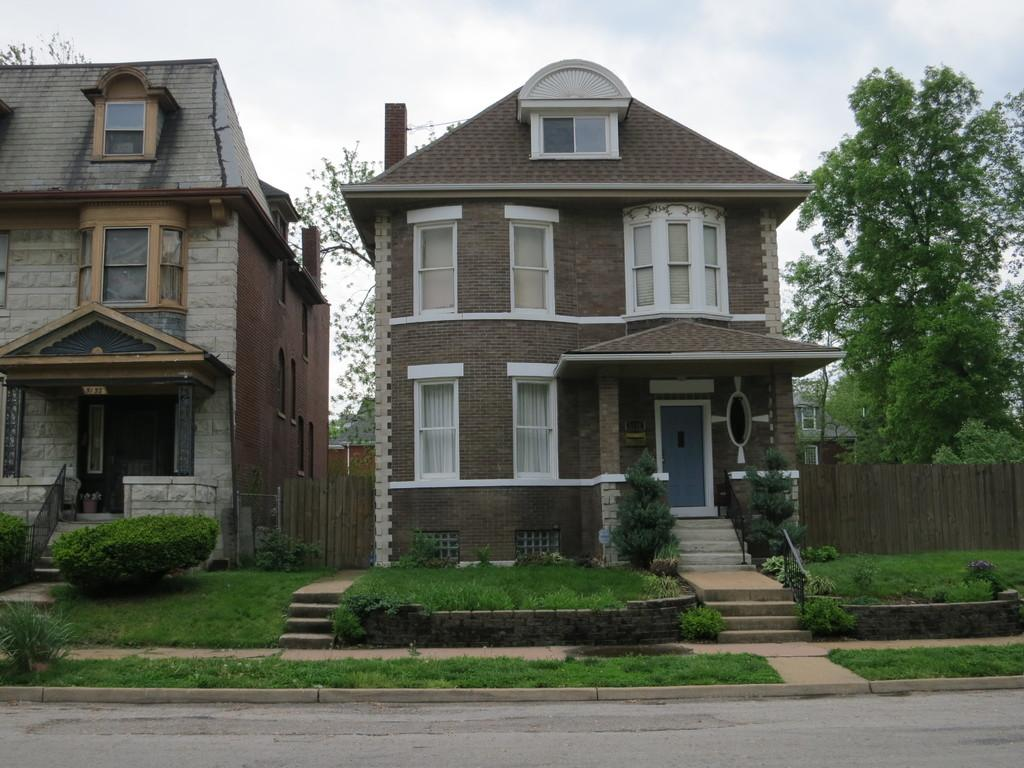What type of structures are visible in the image? There are houses in the image. What is located in front of the houses? There are plants and grass on the surface in front of the houses. What can be seen behind the houses? There are trees behind the houses. What type of bomb is being used to destroy the houses in the image? There is no bomb present in the image, and the houses are not being destroyed. 